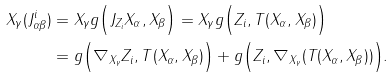<formula> <loc_0><loc_0><loc_500><loc_500>X _ { \gamma } ( J _ { \alpha \beta } ^ { i } ) & = X _ { \gamma } g \Big { ( } J _ { Z _ { i } } X _ { \alpha } , X _ { \beta } \Big { ) } = X _ { \gamma } g \Big { ( } Z _ { i } , T ( X _ { \alpha } , X _ { \beta } ) \Big { ) } \\ & = g \Big { ( } \nabla _ { X _ { \gamma } } Z _ { i } , T ( X _ { \alpha } , X _ { \beta } ) \Big { ) } + g \Big { ( } Z _ { i } , \nabla _ { X _ { \gamma } } ( T ( X _ { \alpha } , X _ { \beta } ) ) \Big { ) } .</formula> 